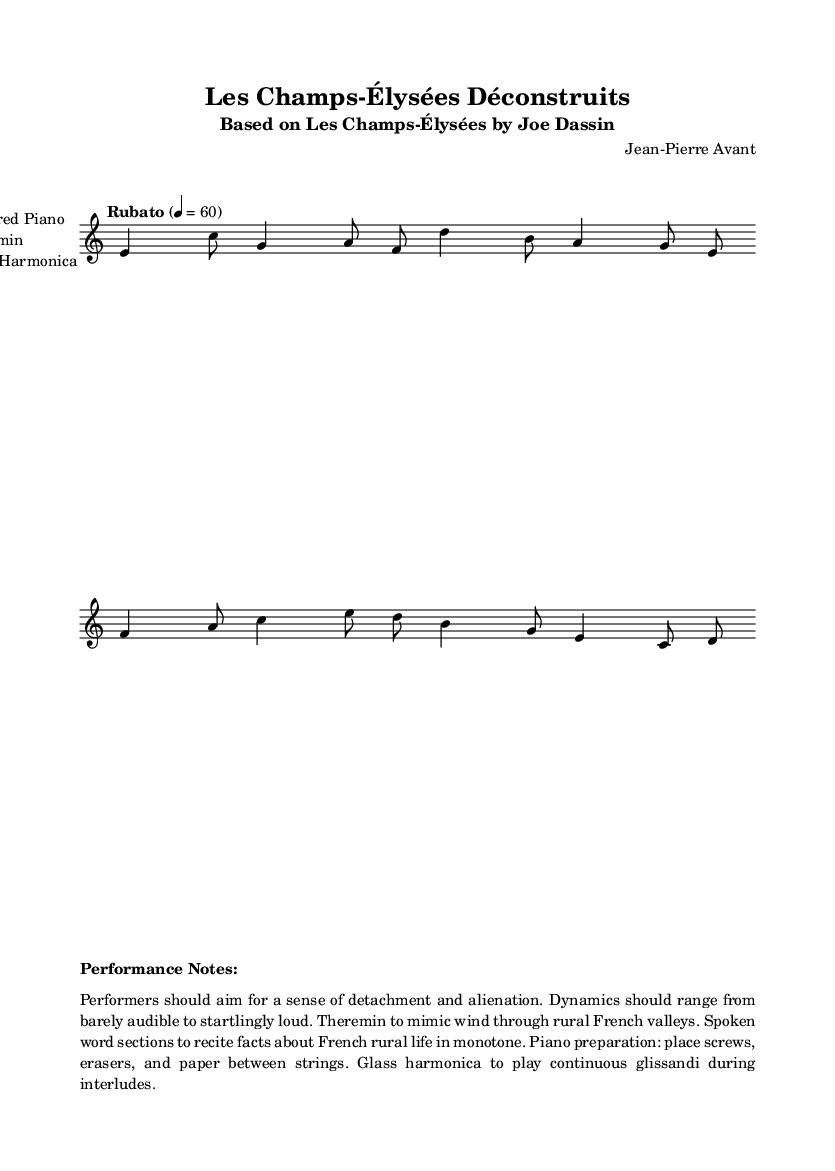What is the time signature of this music? The time signature shown at the beginning of the score is 7/8. This is indicated right after the global settings in the code.
Answer: 7/8 What instruments are featured in this piece? The score specifies three instruments: Prepared Piano, Theremin, and Glass Harmonica. This information is found in the instrumentation section of the score.
Answer: Prepared Piano, Theremin, Glass Harmonica What is the tempo indication for this piece? The tempo instruction states "Rubato," with a metronome marking of 4 = 60. This means the piece should be played with flexibility in tempo, but on average at a tempo of 60 beats per minute.
Answer: Rubato 4 = 60 What type of performance style is suggested for this composition? The performance notes suggest a sense of detachment and alienation, directing performers to create dynamics ranging from almost silent to startlingly loud, which emphasizes the avant-garde nature of the piece.
Answer: Detachment and alienation How many measures does the melody section contain? By examining the provided melody, we can count a total of eight measures, as each combination of notes and bar lines represents one measure in the score.
Answer: Eight What specific technique is suggested for the prepared piano? The performance notes detail that the piano preparation should involve placing screws, erasers, and paper between the strings, which is a common technique in avant-garde music to create unique sounds.
Answer: Screws, erasers, and paper between strings 